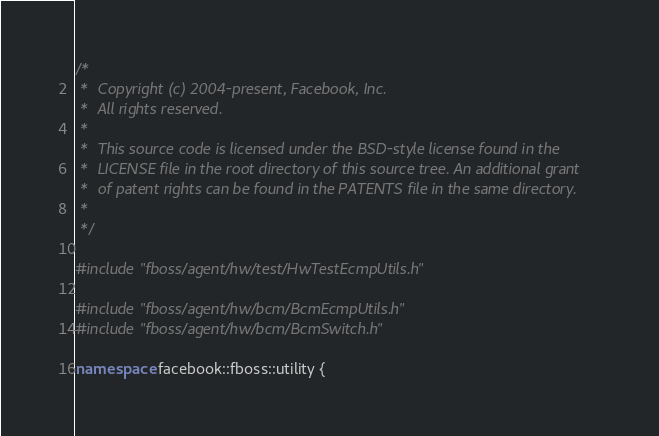<code> <loc_0><loc_0><loc_500><loc_500><_C++_>/*
 *  Copyright (c) 2004-present, Facebook, Inc.
 *  All rights reserved.
 *
 *  This source code is licensed under the BSD-style license found in the
 *  LICENSE file in the root directory of this source tree. An additional grant
 *  of patent rights can be found in the PATENTS file in the same directory.
 *
 */

#include "fboss/agent/hw/test/HwTestEcmpUtils.h"

#include "fboss/agent/hw/bcm/BcmEcmpUtils.h"
#include "fboss/agent/hw/bcm/BcmSwitch.h"

namespace facebook::fboss::utility {
</code> 